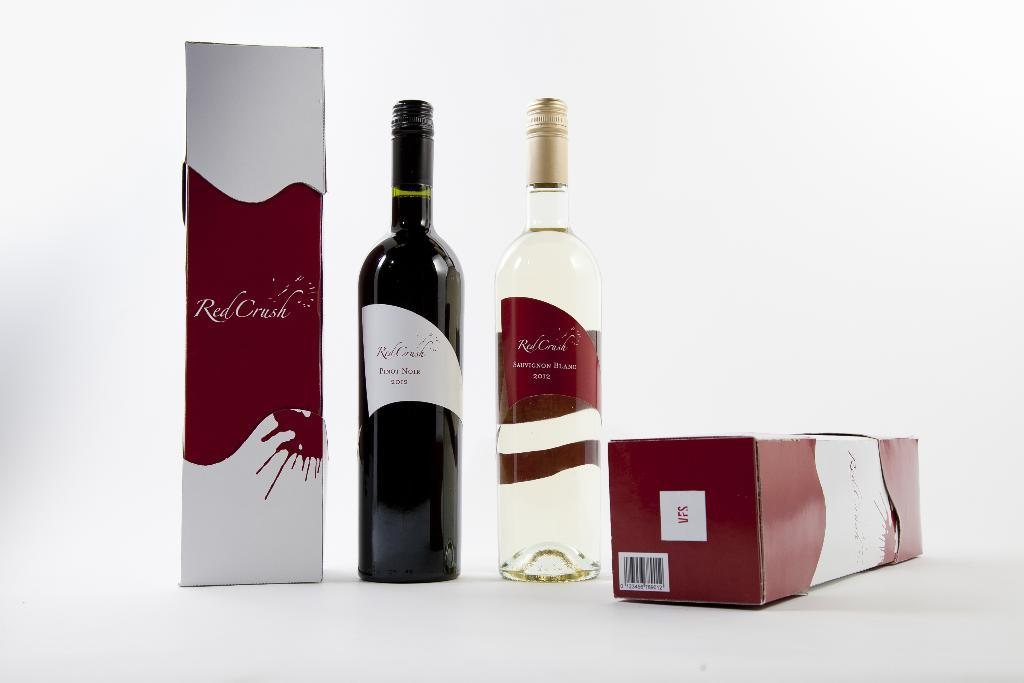How many bottles are visible in the image? There are two bottles in the image. What are the color differences between the two bottles? One bottle is black in color, while the other bottle is transparent. What else can be seen in the image besides the bottles? There are two packets in the image. How does the comfort level of the top change throughout the day in the image? There is no top mentioned in the image, so it's not possible to determine any changes in comfort level. 